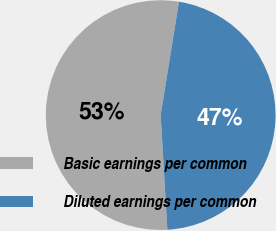Convert chart to OTSL. <chart><loc_0><loc_0><loc_500><loc_500><pie_chart><fcel>Basic earnings per common<fcel>Diluted earnings per common<nl><fcel>53.47%<fcel>46.53%<nl></chart> 